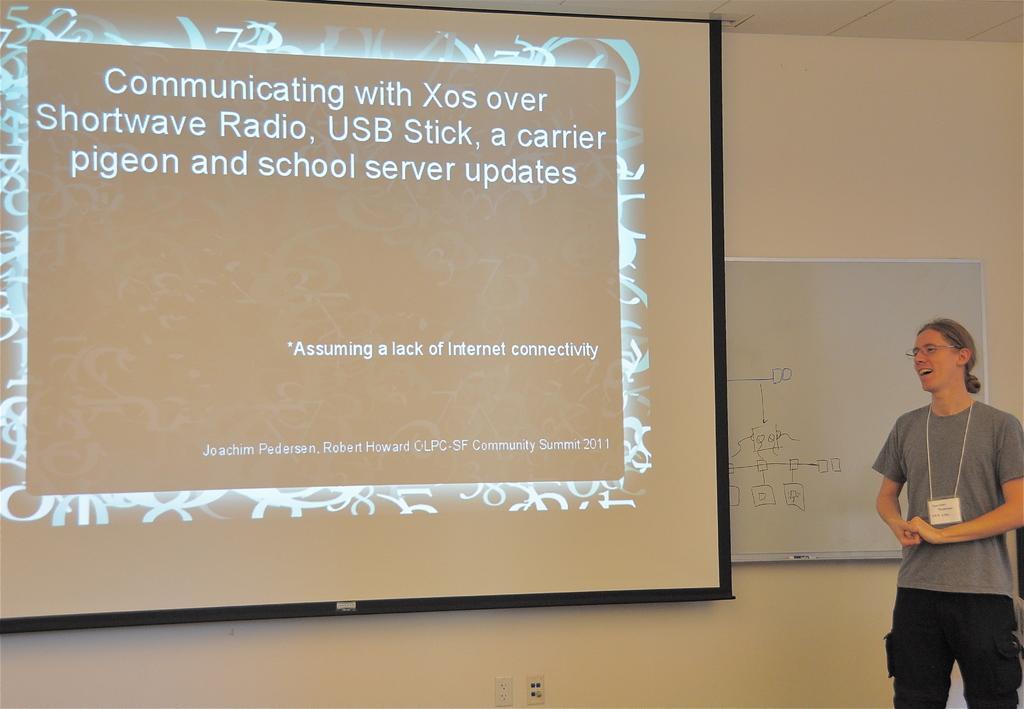In one or two sentences, can you explain what this image depicts? In this picture I can observe a person standing on the left side. In the middle of the picture I can observe projector display screen. I can observe some text in the screen. In the background there is a wall. 